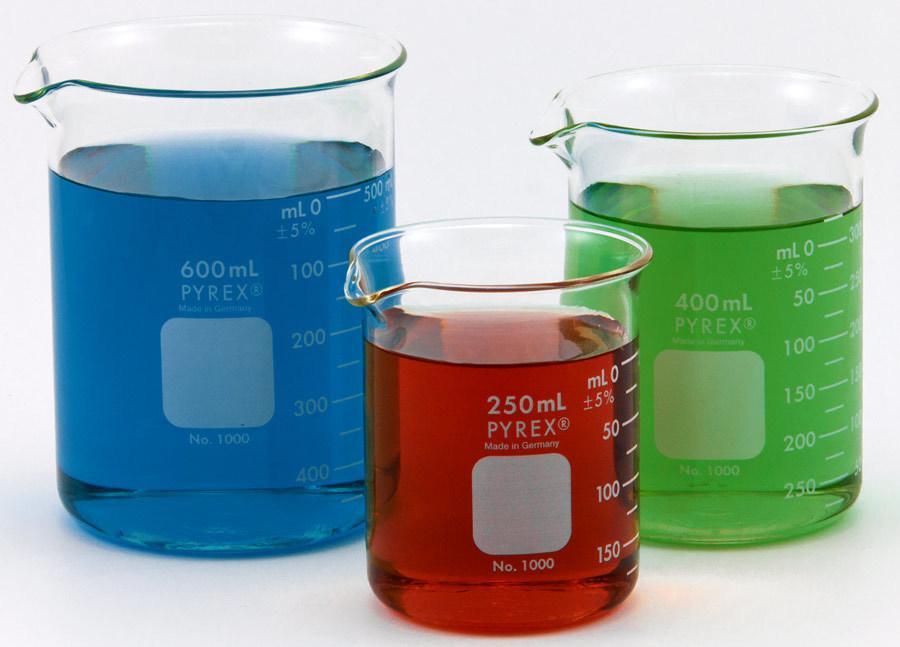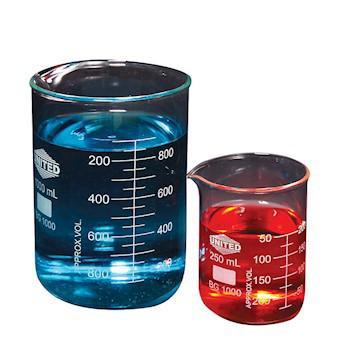The first image is the image on the left, the second image is the image on the right. Given the left and right images, does the statement "The left and right image contains the same number of filled beckers." hold true? Answer yes or no. No. The first image is the image on the left, the second image is the image on the right. For the images shown, is this caption "Every photo shows five containers of colored liquid with two large containers in the back and three small containers in the front." true? Answer yes or no. No. 